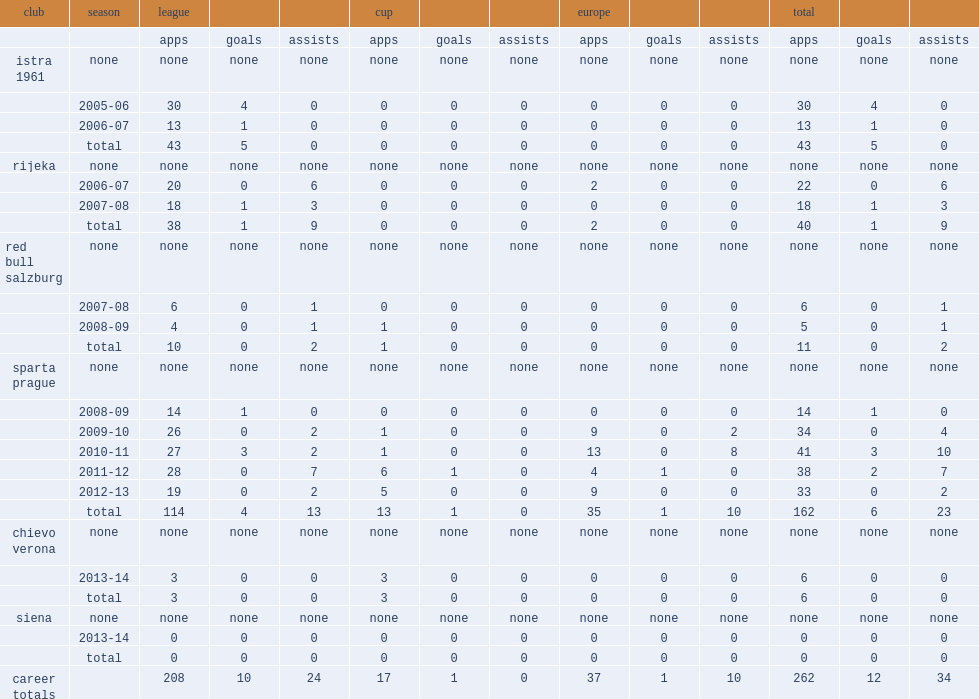How many goals did manue pamic collect in total with sparta? 6.0. 